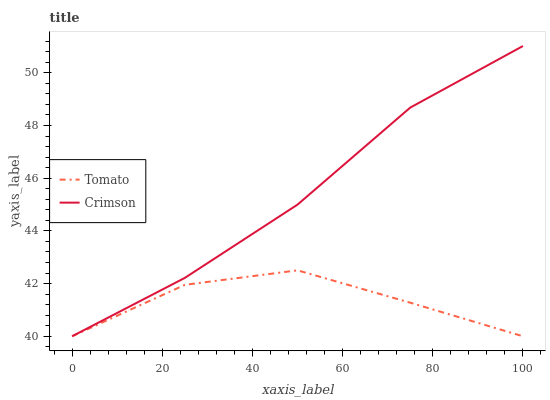Does Tomato have the minimum area under the curve?
Answer yes or no. Yes. Does Crimson have the maximum area under the curve?
Answer yes or no. Yes. Does Crimson have the minimum area under the curve?
Answer yes or no. No. Is Crimson the smoothest?
Answer yes or no. Yes. Is Tomato the roughest?
Answer yes or no. Yes. Is Crimson the roughest?
Answer yes or no. No. Does Crimson have the highest value?
Answer yes or no. Yes. Does Tomato intersect Crimson?
Answer yes or no. Yes. Is Tomato less than Crimson?
Answer yes or no. No. Is Tomato greater than Crimson?
Answer yes or no. No. 